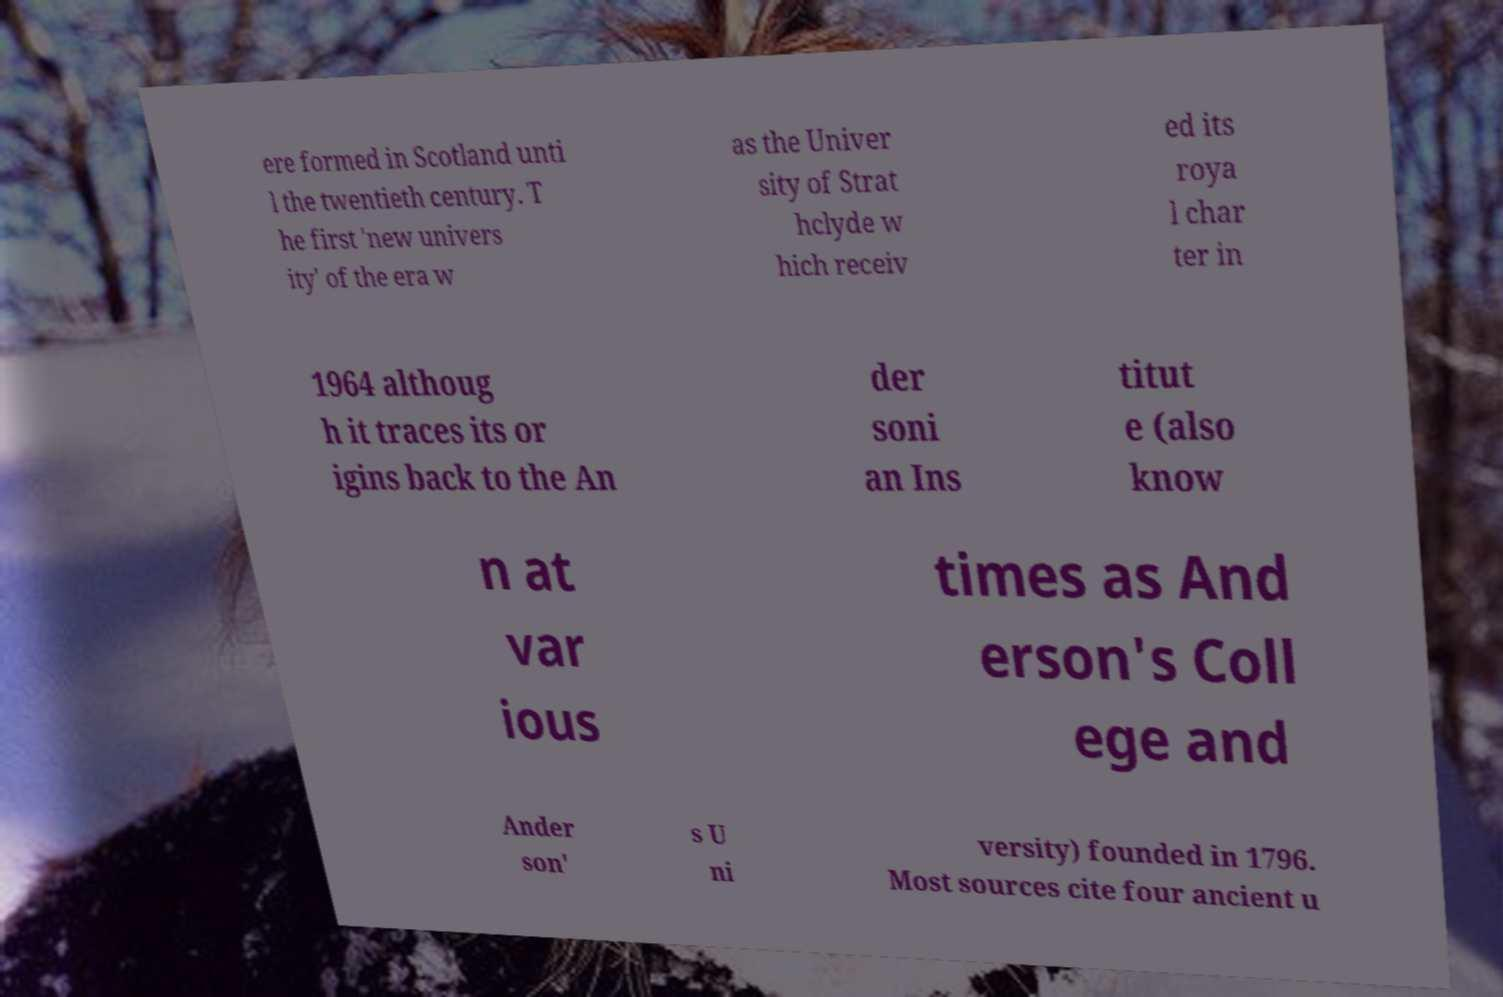Please read and relay the text visible in this image. What does it say? ere formed in Scotland unti l the twentieth century. T he first 'new univers ity' of the era w as the Univer sity of Strat hclyde w hich receiv ed its roya l char ter in 1964 althoug h it traces its or igins back to the An der soni an Ins titut e (also know n at var ious times as And erson's Coll ege and Ander son' s U ni versity) founded in 1796. Most sources cite four ancient u 